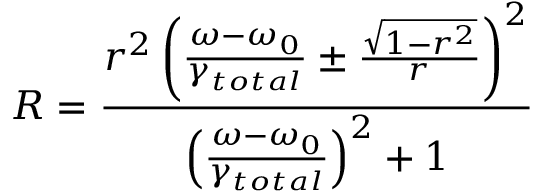<formula> <loc_0><loc_0><loc_500><loc_500>R = \frac { r ^ { 2 } \left ( \frac { \omega - \omega _ { 0 } } { \gamma _ { t o t a l } } \pm \frac { \sqrt { 1 - r ^ { 2 } } } { r } \right ) ^ { 2 } } { \left ( \frac { \omega - \omega _ { 0 } } { \gamma _ { t o t a l } } \right ) ^ { 2 } + 1 }</formula> 